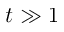<formula> <loc_0><loc_0><loc_500><loc_500>t \gg 1</formula> 